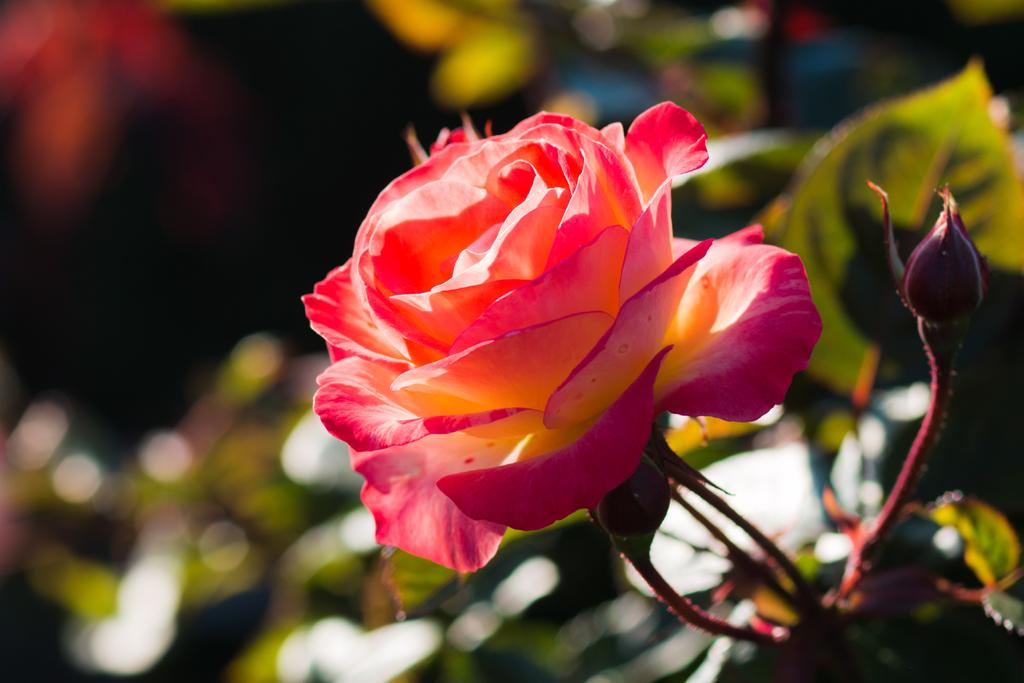What is the main subject of the image? There is a flower in the image. Can you describe the flower in more detail? There is a bud on the stem of the flower. What else can be seen in the background of the image? There is a blurred picture of a plant in the background. What type of cushion is being used by the committee in the image? There is no cushion or committee present in the image; it features a flower with a bud on the stem and a blurred picture of a plant in the background. 